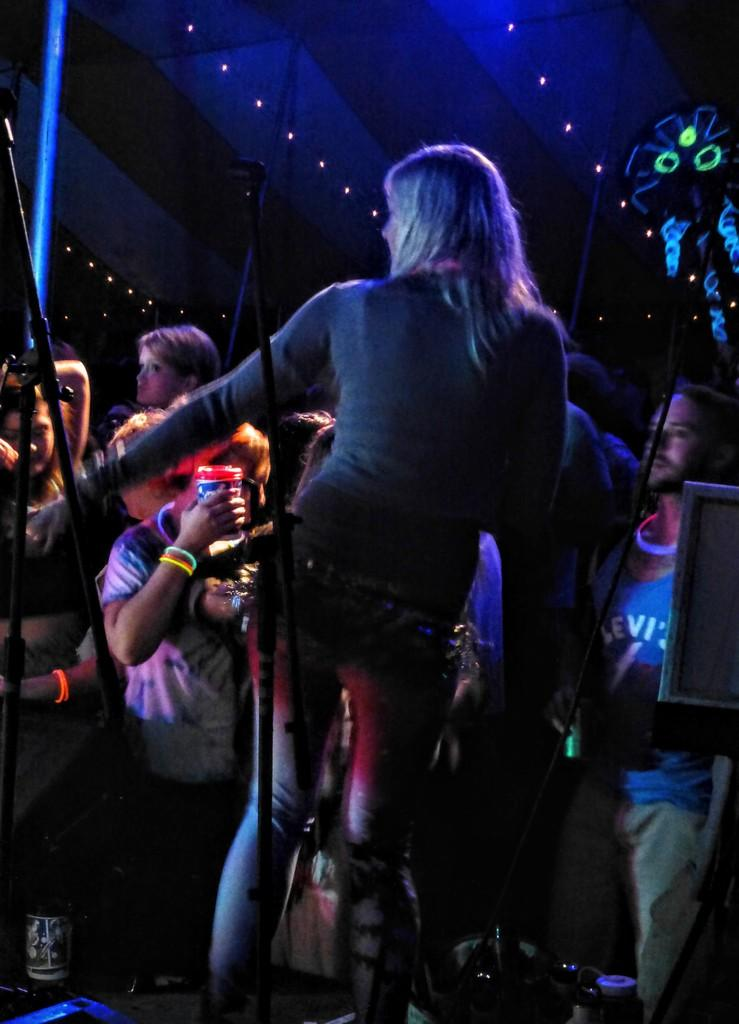What is happening in the image? There are people standing in the image. What can be seen at the top of the image? There are lights visible at the top of the image. What type of food is being prepared by the people in the image? There is no food preparation or reference to food in the image. 